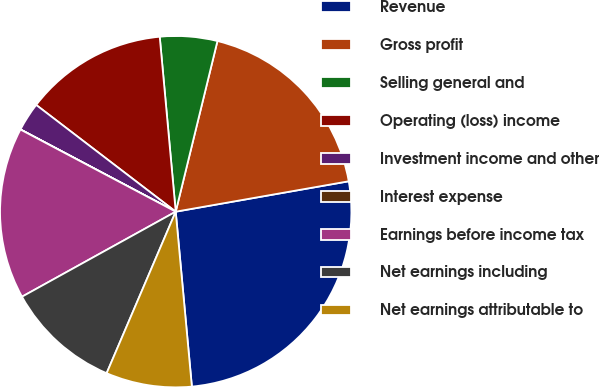<chart> <loc_0><loc_0><loc_500><loc_500><pie_chart><fcel>Revenue<fcel>Gross profit<fcel>Selling general and<fcel>Operating (loss) income<fcel>Investment income and other<fcel>Interest expense<fcel>Earnings before income tax<fcel>Net earnings including<fcel>Net earnings attributable to<nl><fcel>26.31%<fcel>18.42%<fcel>5.27%<fcel>13.16%<fcel>2.64%<fcel>0.01%<fcel>15.79%<fcel>10.53%<fcel>7.9%<nl></chart> 